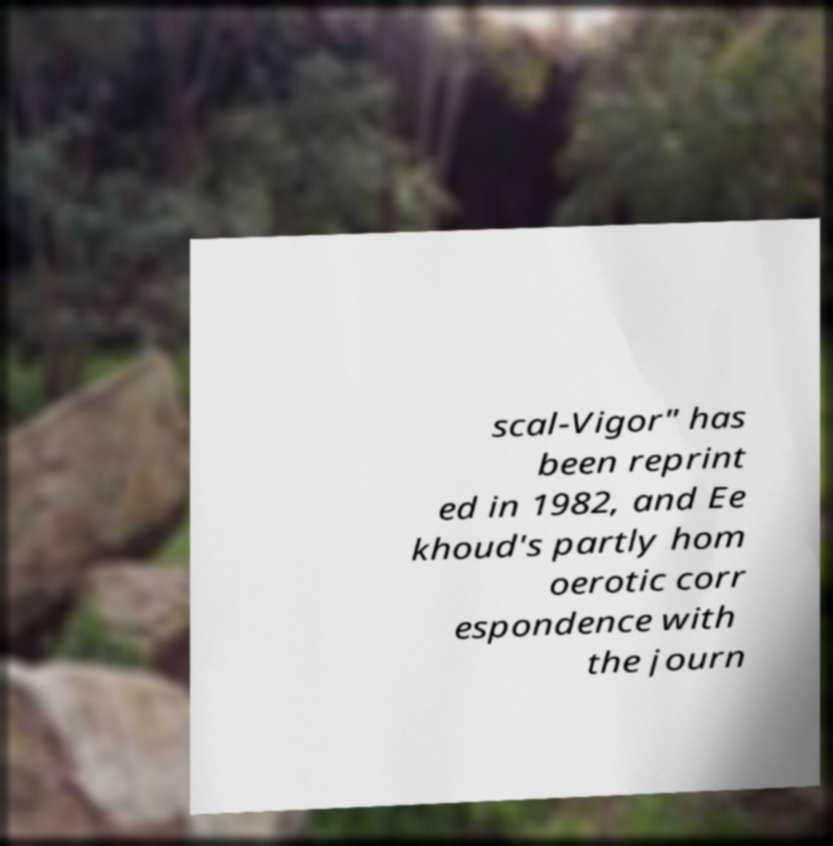Could you assist in decoding the text presented in this image and type it out clearly? scal-Vigor" has been reprint ed in 1982, and Ee khoud's partly hom oerotic corr espondence with the journ 